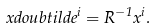Convert formula to latex. <formula><loc_0><loc_0><loc_500><loc_500>\ x d o u b t i l d e ^ { i } = R ^ { - 1 } x ^ { i } .</formula> 